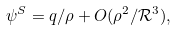Convert formula to latex. <formula><loc_0><loc_0><loc_500><loc_500>\psi ^ { S } = q / \rho + O ( \rho ^ { 2 } / \mathcal { R } ^ { 3 } ) ,</formula> 